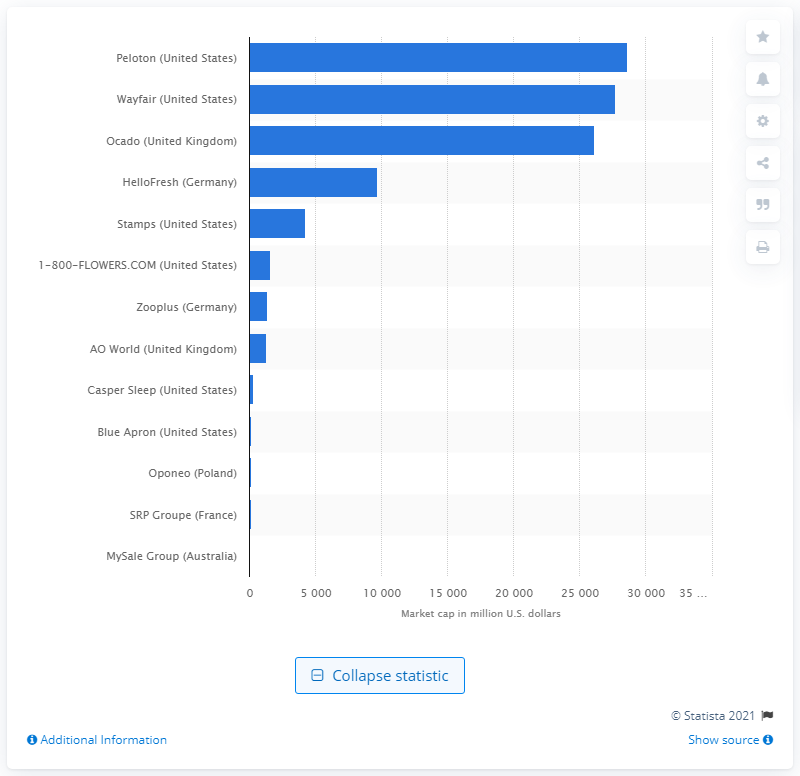Give some essential details in this illustration. Wayfair's market capitalization is currently 27,760. Peloton's market capitalization is currently 28,649. 